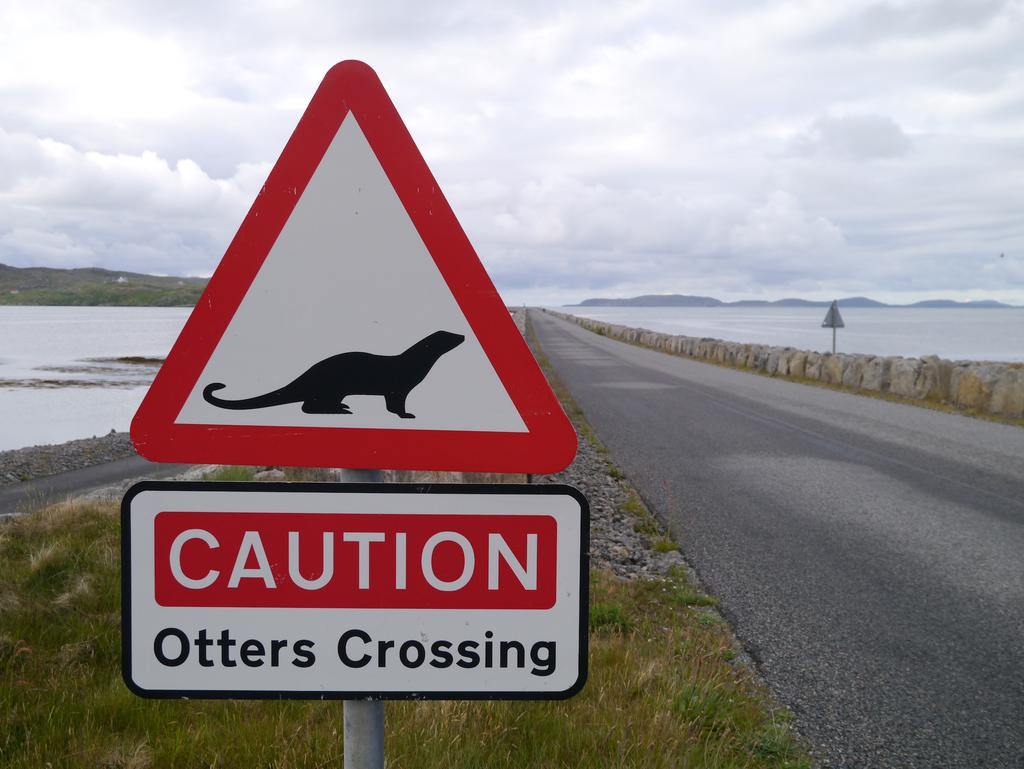<image>
Give a short and clear explanation of the subsequent image. A caution sign warning about Otters crossing here. 